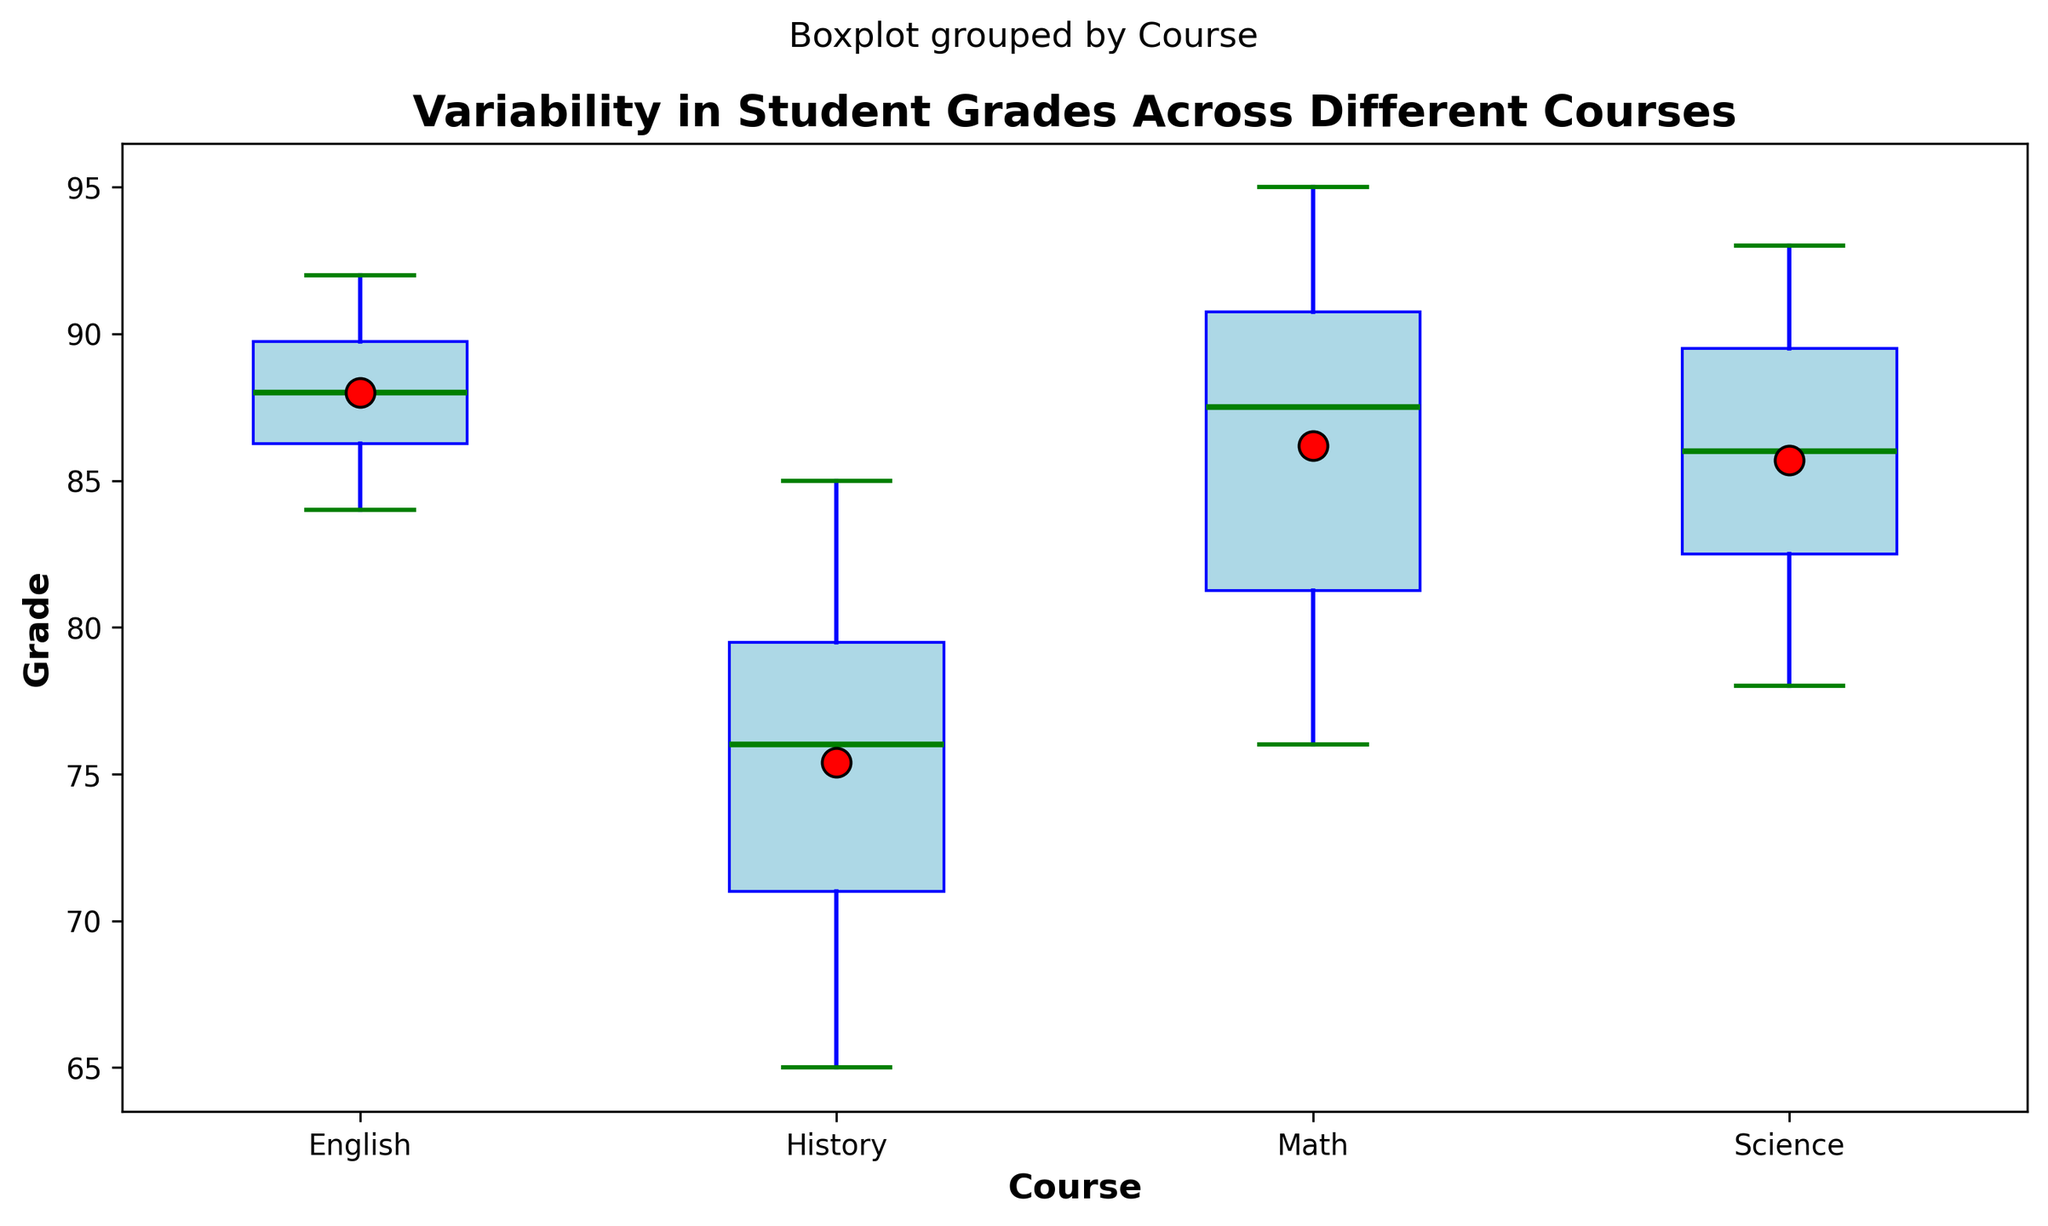Which course has the highest median grade? To determine the course with the highest median grade, examine the central green line within each box plot. The highest median value appears in the English course plot.
Answer: English Which course shows the greatest variability in student grades? Look at the lengths of the boxes and the whiskers, which represent variability. The History course box plot has the widest span between the minimum and maximum grades.
Answer: History Which course has the smallest mean grade? The mean grade is indicated by a red dot within each box plot. The lowest red dot appears in the History course plot.
Answer: History Compare the interquartile ranges of Math and Science. Which one is larger? The interquartile range (IQR) is represented by the height of the boxes. The height of the Math box is shorter than that of the Science box, so the IQR for Science is larger.
Answer: Science Is the mean grade for the English course greater than the median grade for the Science course? Check the red dot in the English course box plot and the central green line in the Science course plot. The mean grade for English (red dot) is higher than the median grade for Science (green line).
Answer: Yes Which course has the most outliers? Outliers are shown as individual points (diamonds) outside the whiskers. The History course has the most outliers, shown by multiple red diamond points.
Answer: History How does the median grade for Math compare to the mean grade for Science? Look at the green line in Math's box plot for the median and the red dot in Science's box plot for the mean. The median grade for Math is roughly equal to the mean grade for Science.
Answer: Roughly equal Rank the courses from highest to lowest based on the maximum grade observed. Check the top ends of the whiskers for each course. The rankings, from highest to lowest, are English, Science, Math, and History.
Answer: English > Science > Math > History Calculate the approximate range for English grades. The range is the difference between the maximum and minimum grades. The whiskers for English box plot show a range roughly from 84 to 92. So, the range is approximately 92 - 84 = 8.
Answer: 8 Which course has the closest mean and median grades? Compare the red dot and green line positions within each box plot. The Math course has the mean and median grades closest to each other.
Answer: Math 